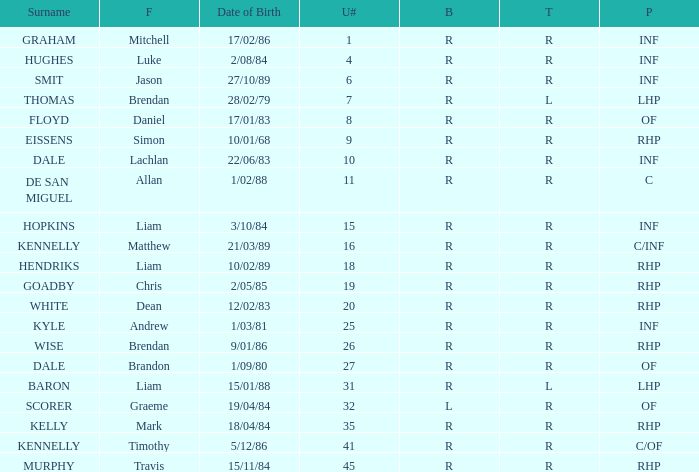Which batter has a uni# of 31? R. 